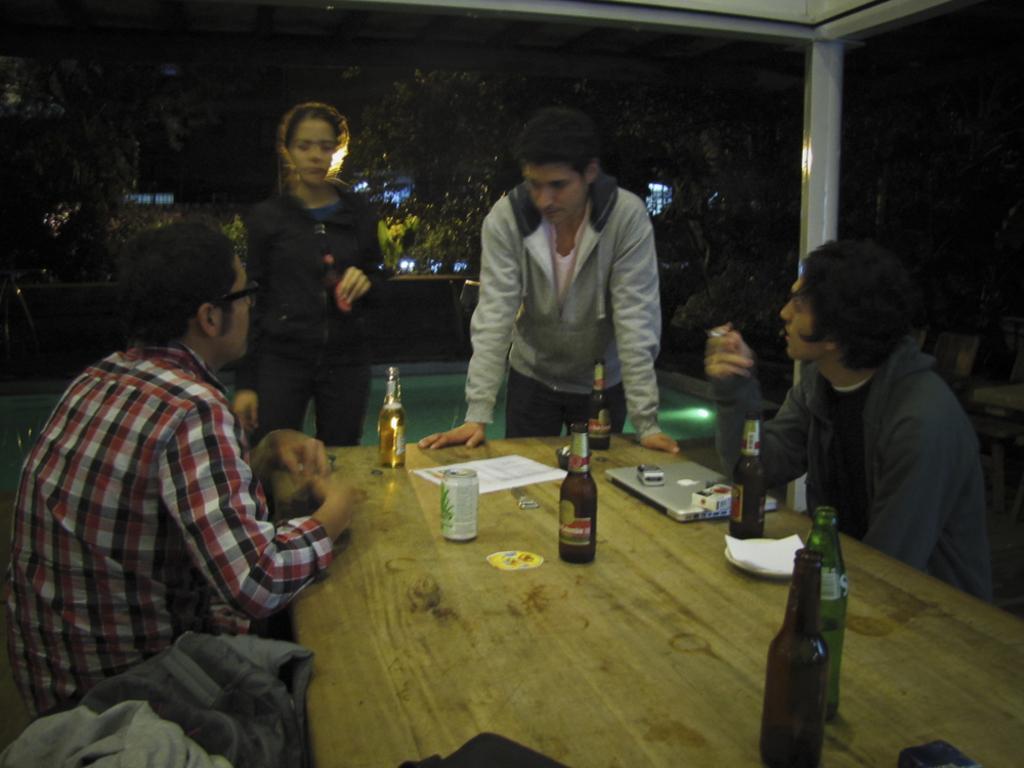Could you give a brief overview of what you see in this image? In the middle there are two persons standing and on the right and left men are sitting on the chair. In the middle there is a table,on the table we can see wine bottles,laptop,tissue papers and tin. In the background we can see trees. 